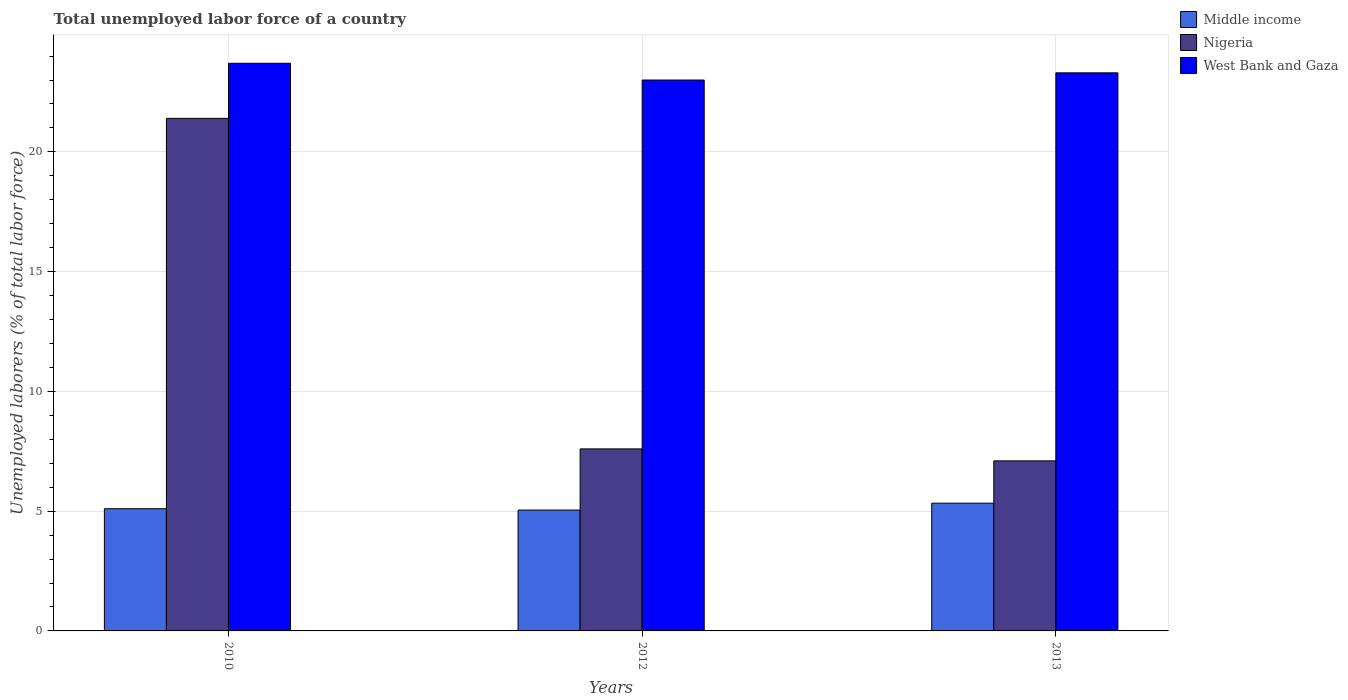How many different coloured bars are there?
Offer a terse response. 3. How many groups of bars are there?
Your answer should be compact. 3. Are the number of bars on each tick of the X-axis equal?
Your answer should be very brief. Yes. How many bars are there on the 3rd tick from the left?
Offer a terse response. 3. What is the label of the 1st group of bars from the left?
Offer a terse response. 2010. In how many cases, is the number of bars for a given year not equal to the number of legend labels?
Offer a very short reply. 0. What is the total unemployed labor force in West Bank and Gaza in 2012?
Your answer should be compact. 23. Across all years, what is the maximum total unemployed labor force in West Bank and Gaza?
Keep it short and to the point. 23.7. What is the total total unemployed labor force in Middle income in the graph?
Ensure brevity in your answer.  15.48. What is the difference between the total unemployed labor force in West Bank and Gaza in 2010 and that in 2013?
Your answer should be compact. 0.4. What is the difference between the total unemployed labor force in Nigeria in 2012 and the total unemployed labor force in Middle income in 2013?
Ensure brevity in your answer.  2.27. What is the average total unemployed labor force in Middle income per year?
Keep it short and to the point. 5.16. In the year 2012, what is the difference between the total unemployed labor force in Middle income and total unemployed labor force in Nigeria?
Your response must be concise. -2.55. In how many years, is the total unemployed labor force in Nigeria greater than 23 %?
Provide a succinct answer. 0. What is the ratio of the total unemployed labor force in West Bank and Gaza in 2010 to that in 2012?
Your answer should be very brief. 1.03. Is the difference between the total unemployed labor force in Middle income in 2010 and 2012 greater than the difference between the total unemployed labor force in Nigeria in 2010 and 2012?
Ensure brevity in your answer.  No. What is the difference between the highest and the second highest total unemployed labor force in Middle income?
Ensure brevity in your answer.  0.23. What is the difference between the highest and the lowest total unemployed labor force in Nigeria?
Your answer should be very brief. 14.3. In how many years, is the total unemployed labor force in Middle income greater than the average total unemployed labor force in Middle income taken over all years?
Provide a succinct answer. 1. What does the 2nd bar from the right in 2013 represents?
Offer a terse response. Nigeria. Is it the case that in every year, the sum of the total unemployed labor force in West Bank and Gaza and total unemployed labor force in Middle income is greater than the total unemployed labor force in Nigeria?
Make the answer very short. Yes. How many years are there in the graph?
Offer a terse response. 3. What is the difference between two consecutive major ticks on the Y-axis?
Ensure brevity in your answer.  5. Are the values on the major ticks of Y-axis written in scientific E-notation?
Your answer should be very brief. No. Does the graph contain any zero values?
Offer a very short reply. No. Where does the legend appear in the graph?
Your answer should be very brief. Top right. How many legend labels are there?
Keep it short and to the point. 3. What is the title of the graph?
Provide a short and direct response. Total unemployed labor force of a country. Does "Ethiopia" appear as one of the legend labels in the graph?
Your response must be concise. No. What is the label or title of the X-axis?
Your answer should be compact. Years. What is the label or title of the Y-axis?
Ensure brevity in your answer.  Unemployed laborers (% of total labor force). What is the Unemployed laborers (% of total labor force) of Middle income in 2010?
Provide a short and direct response. 5.1. What is the Unemployed laborers (% of total labor force) in Nigeria in 2010?
Offer a terse response. 21.4. What is the Unemployed laborers (% of total labor force) in West Bank and Gaza in 2010?
Ensure brevity in your answer.  23.7. What is the Unemployed laborers (% of total labor force) of Middle income in 2012?
Provide a short and direct response. 5.05. What is the Unemployed laborers (% of total labor force) in Nigeria in 2012?
Give a very brief answer. 7.6. What is the Unemployed laborers (% of total labor force) in Middle income in 2013?
Give a very brief answer. 5.33. What is the Unemployed laborers (% of total labor force) of Nigeria in 2013?
Your answer should be compact. 7.1. What is the Unemployed laborers (% of total labor force) in West Bank and Gaza in 2013?
Give a very brief answer. 23.3. Across all years, what is the maximum Unemployed laborers (% of total labor force) in Middle income?
Give a very brief answer. 5.33. Across all years, what is the maximum Unemployed laborers (% of total labor force) in Nigeria?
Your answer should be very brief. 21.4. Across all years, what is the maximum Unemployed laborers (% of total labor force) of West Bank and Gaza?
Provide a succinct answer. 23.7. Across all years, what is the minimum Unemployed laborers (% of total labor force) in Middle income?
Provide a succinct answer. 5.05. Across all years, what is the minimum Unemployed laborers (% of total labor force) of Nigeria?
Offer a terse response. 7.1. What is the total Unemployed laborers (% of total labor force) of Middle income in the graph?
Your response must be concise. 15.48. What is the total Unemployed laborers (% of total labor force) of Nigeria in the graph?
Provide a succinct answer. 36.1. What is the difference between the Unemployed laborers (% of total labor force) in Middle income in 2010 and that in 2012?
Your answer should be very brief. 0.06. What is the difference between the Unemployed laborers (% of total labor force) of Nigeria in 2010 and that in 2012?
Your response must be concise. 13.8. What is the difference between the Unemployed laborers (% of total labor force) in Middle income in 2010 and that in 2013?
Your answer should be compact. -0.23. What is the difference between the Unemployed laborers (% of total labor force) of Nigeria in 2010 and that in 2013?
Your answer should be compact. 14.3. What is the difference between the Unemployed laborers (% of total labor force) of Middle income in 2012 and that in 2013?
Give a very brief answer. -0.29. What is the difference between the Unemployed laborers (% of total labor force) in Nigeria in 2012 and that in 2013?
Ensure brevity in your answer.  0.5. What is the difference between the Unemployed laborers (% of total labor force) of Middle income in 2010 and the Unemployed laborers (% of total labor force) of Nigeria in 2012?
Your answer should be compact. -2.5. What is the difference between the Unemployed laborers (% of total labor force) in Middle income in 2010 and the Unemployed laborers (% of total labor force) in West Bank and Gaza in 2012?
Your response must be concise. -17.9. What is the difference between the Unemployed laborers (% of total labor force) in Nigeria in 2010 and the Unemployed laborers (% of total labor force) in West Bank and Gaza in 2012?
Your answer should be very brief. -1.6. What is the difference between the Unemployed laborers (% of total labor force) in Middle income in 2010 and the Unemployed laborers (% of total labor force) in Nigeria in 2013?
Ensure brevity in your answer.  -2. What is the difference between the Unemployed laborers (% of total labor force) of Middle income in 2010 and the Unemployed laborers (% of total labor force) of West Bank and Gaza in 2013?
Ensure brevity in your answer.  -18.2. What is the difference between the Unemployed laborers (% of total labor force) of Middle income in 2012 and the Unemployed laborers (% of total labor force) of Nigeria in 2013?
Your answer should be compact. -2.05. What is the difference between the Unemployed laborers (% of total labor force) in Middle income in 2012 and the Unemployed laborers (% of total labor force) in West Bank and Gaza in 2013?
Give a very brief answer. -18.25. What is the difference between the Unemployed laborers (% of total labor force) of Nigeria in 2012 and the Unemployed laborers (% of total labor force) of West Bank and Gaza in 2013?
Keep it short and to the point. -15.7. What is the average Unemployed laborers (% of total labor force) in Middle income per year?
Your answer should be compact. 5.16. What is the average Unemployed laborers (% of total labor force) of Nigeria per year?
Offer a terse response. 12.03. What is the average Unemployed laborers (% of total labor force) of West Bank and Gaza per year?
Offer a very short reply. 23.33. In the year 2010, what is the difference between the Unemployed laborers (% of total labor force) of Middle income and Unemployed laborers (% of total labor force) of Nigeria?
Offer a very short reply. -16.3. In the year 2010, what is the difference between the Unemployed laborers (% of total labor force) of Middle income and Unemployed laborers (% of total labor force) of West Bank and Gaza?
Keep it short and to the point. -18.6. In the year 2012, what is the difference between the Unemployed laborers (% of total labor force) of Middle income and Unemployed laborers (% of total labor force) of Nigeria?
Provide a succinct answer. -2.55. In the year 2012, what is the difference between the Unemployed laborers (% of total labor force) in Middle income and Unemployed laborers (% of total labor force) in West Bank and Gaza?
Keep it short and to the point. -17.95. In the year 2012, what is the difference between the Unemployed laborers (% of total labor force) of Nigeria and Unemployed laborers (% of total labor force) of West Bank and Gaza?
Keep it short and to the point. -15.4. In the year 2013, what is the difference between the Unemployed laborers (% of total labor force) of Middle income and Unemployed laborers (% of total labor force) of Nigeria?
Offer a terse response. -1.77. In the year 2013, what is the difference between the Unemployed laborers (% of total labor force) in Middle income and Unemployed laborers (% of total labor force) in West Bank and Gaza?
Provide a succinct answer. -17.97. In the year 2013, what is the difference between the Unemployed laborers (% of total labor force) of Nigeria and Unemployed laborers (% of total labor force) of West Bank and Gaza?
Make the answer very short. -16.2. What is the ratio of the Unemployed laborers (% of total labor force) in Middle income in 2010 to that in 2012?
Provide a succinct answer. 1.01. What is the ratio of the Unemployed laborers (% of total labor force) in Nigeria in 2010 to that in 2012?
Offer a very short reply. 2.82. What is the ratio of the Unemployed laborers (% of total labor force) in West Bank and Gaza in 2010 to that in 2012?
Your answer should be very brief. 1.03. What is the ratio of the Unemployed laborers (% of total labor force) of Middle income in 2010 to that in 2013?
Ensure brevity in your answer.  0.96. What is the ratio of the Unemployed laborers (% of total labor force) in Nigeria in 2010 to that in 2013?
Ensure brevity in your answer.  3.01. What is the ratio of the Unemployed laborers (% of total labor force) in West Bank and Gaza in 2010 to that in 2013?
Provide a succinct answer. 1.02. What is the ratio of the Unemployed laborers (% of total labor force) of Middle income in 2012 to that in 2013?
Your answer should be very brief. 0.95. What is the ratio of the Unemployed laborers (% of total labor force) of Nigeria in 2012 to that in 2013?
Ensure brevity in your answer.  1.07. What is the ratio of the Unemployed laborers (% of total labor force) in West Bank and Gaza in 2012 to that in 2013?
Offer a very short reply. 0.99. What is the difference between the highest and the second highest Unemployed laborers (% of total labor force) of Middle income?
Give a very brief answer. 0.23. What is the difference between the highest and the second highest Unemployed laborers (% of total labor force) of West Bank and Gaza?
Offer a terse response. 0.4. What is the difference between the highest and the lowest Unemployed laborers (% of total labor force) of Middle income?
Make the answer very short. 0.29. What is the difference between the highest and the lowest Unemployed laborers (% of total labor force) of West Bank and Gaza?
Your response must be concise. 0.7. 